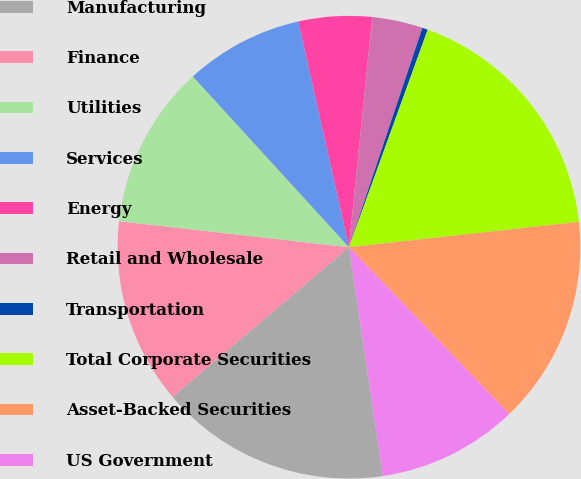Convert chart to OTSL. <chart><loc_0><loc_0><loc_500><loc_500><pie_chart><fcel>Manufacturing<fcel>Finance<fcel>Utilities<fcel>Services<fcel>Energy<fcel>Retail and Wholesale<fcel>Transportation<fcel>Total Corporate Securities<fcel>Asset-Backed Securities<fcel>US Government<nl><fcel>16.14%<fcel>12.99%<fcel>11.42%<fcel>8.27%<fcel>5.12%<fcel>3.54%<fcel>0.39%<fcel>17.72%<fcel>14.57%<fcel>9.84%<nl></chart> 